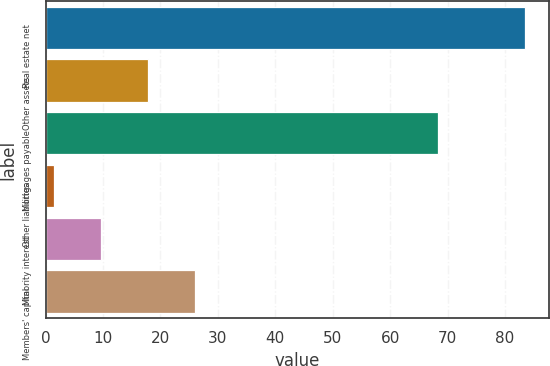<chart> <loc_0><loc_0><loc_500><loc_500><bar_chart><fcel>Real estate net<fcel>Other assets<fcel>Mortgages payable<fcel>Other liabilities<fcel>Minority interest<fcel>Members' capital<nl><fcel>83.5<fcel>17.82<fcel>68.4<fcel>1.4<fcel>9.61<fcel>26.03<nl></chart> 